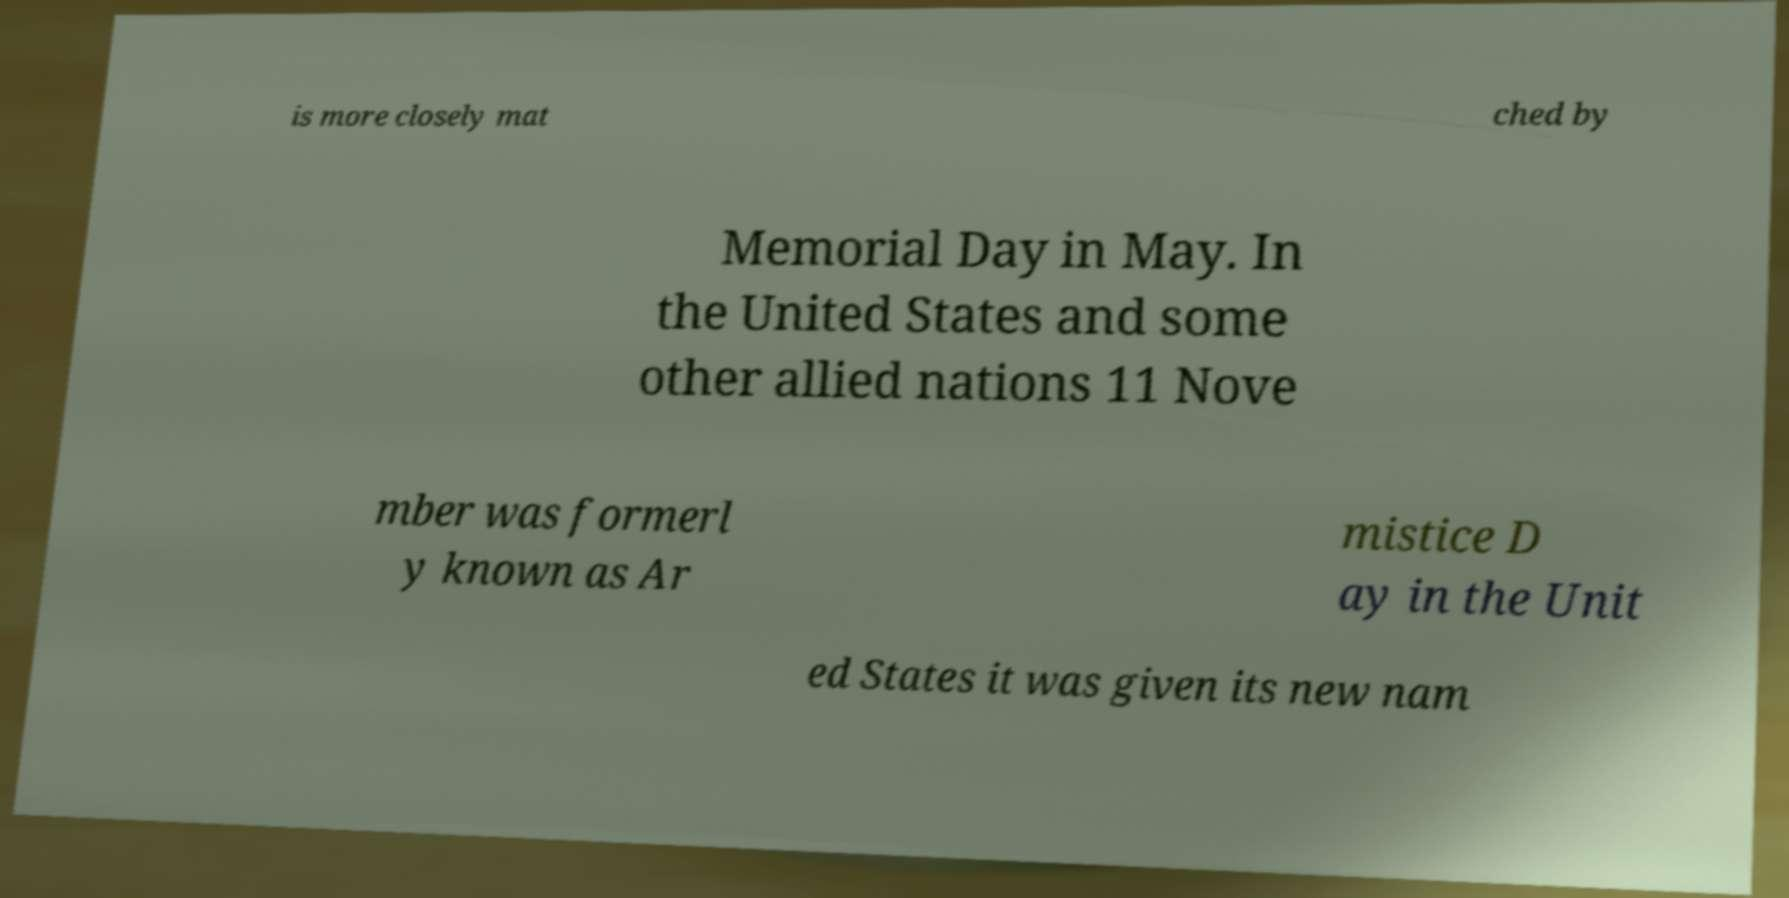Please read and relay the text visible in this image. What does it say? is more closely mat ched by Memorial Day in May. In the United States and some other allied nations 11 Nove mber was formerl y known as Ar mistice D ay in the Unit ed States it was given its new nam 